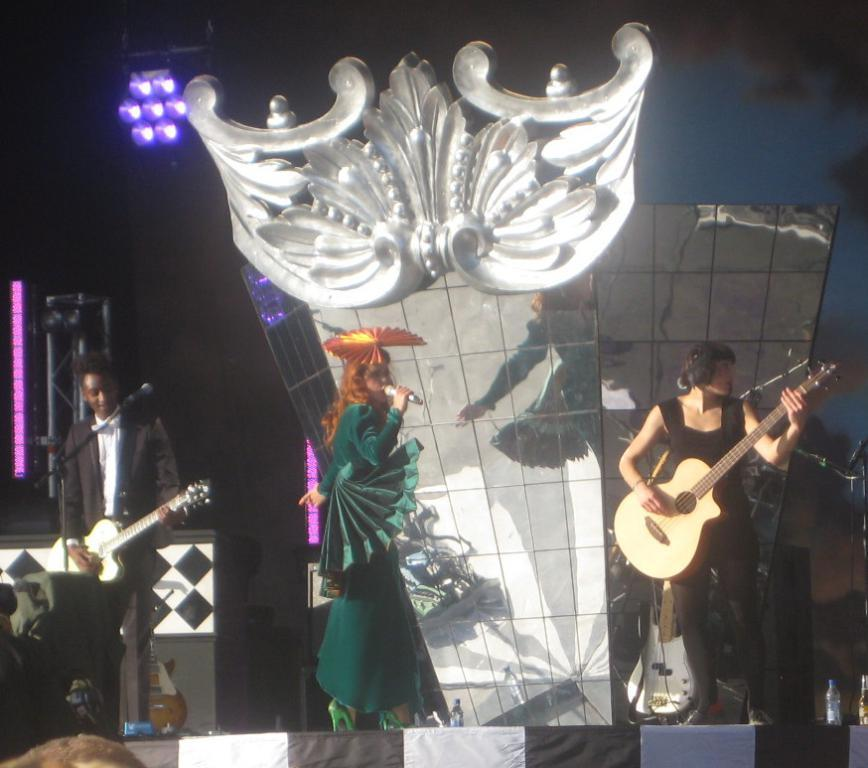How many people are in the image? There are three persons in the image. Where are the persons located? The persons are standing on a stage. What are the persons doing on the stage? The persons are playing musical instruments. What can be seen in the background of the image? There is a frame and a light in the background of the image. What color is the flame coming out of the hydrant in the image? There is no hydrant or flame present in the image. Can you describe the relationship between the father and the persons playing musical instruments in the image? There is no mention of a father or any familial relationships in the image. 